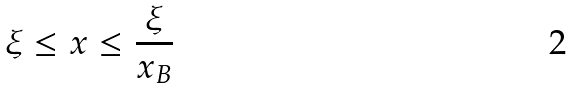Convert formula to latex. <formula><loc_0><loc_0><loc_500><loc_500>\xi \leq x \leq \frac { \xi } { x _ { B } }</formula> 